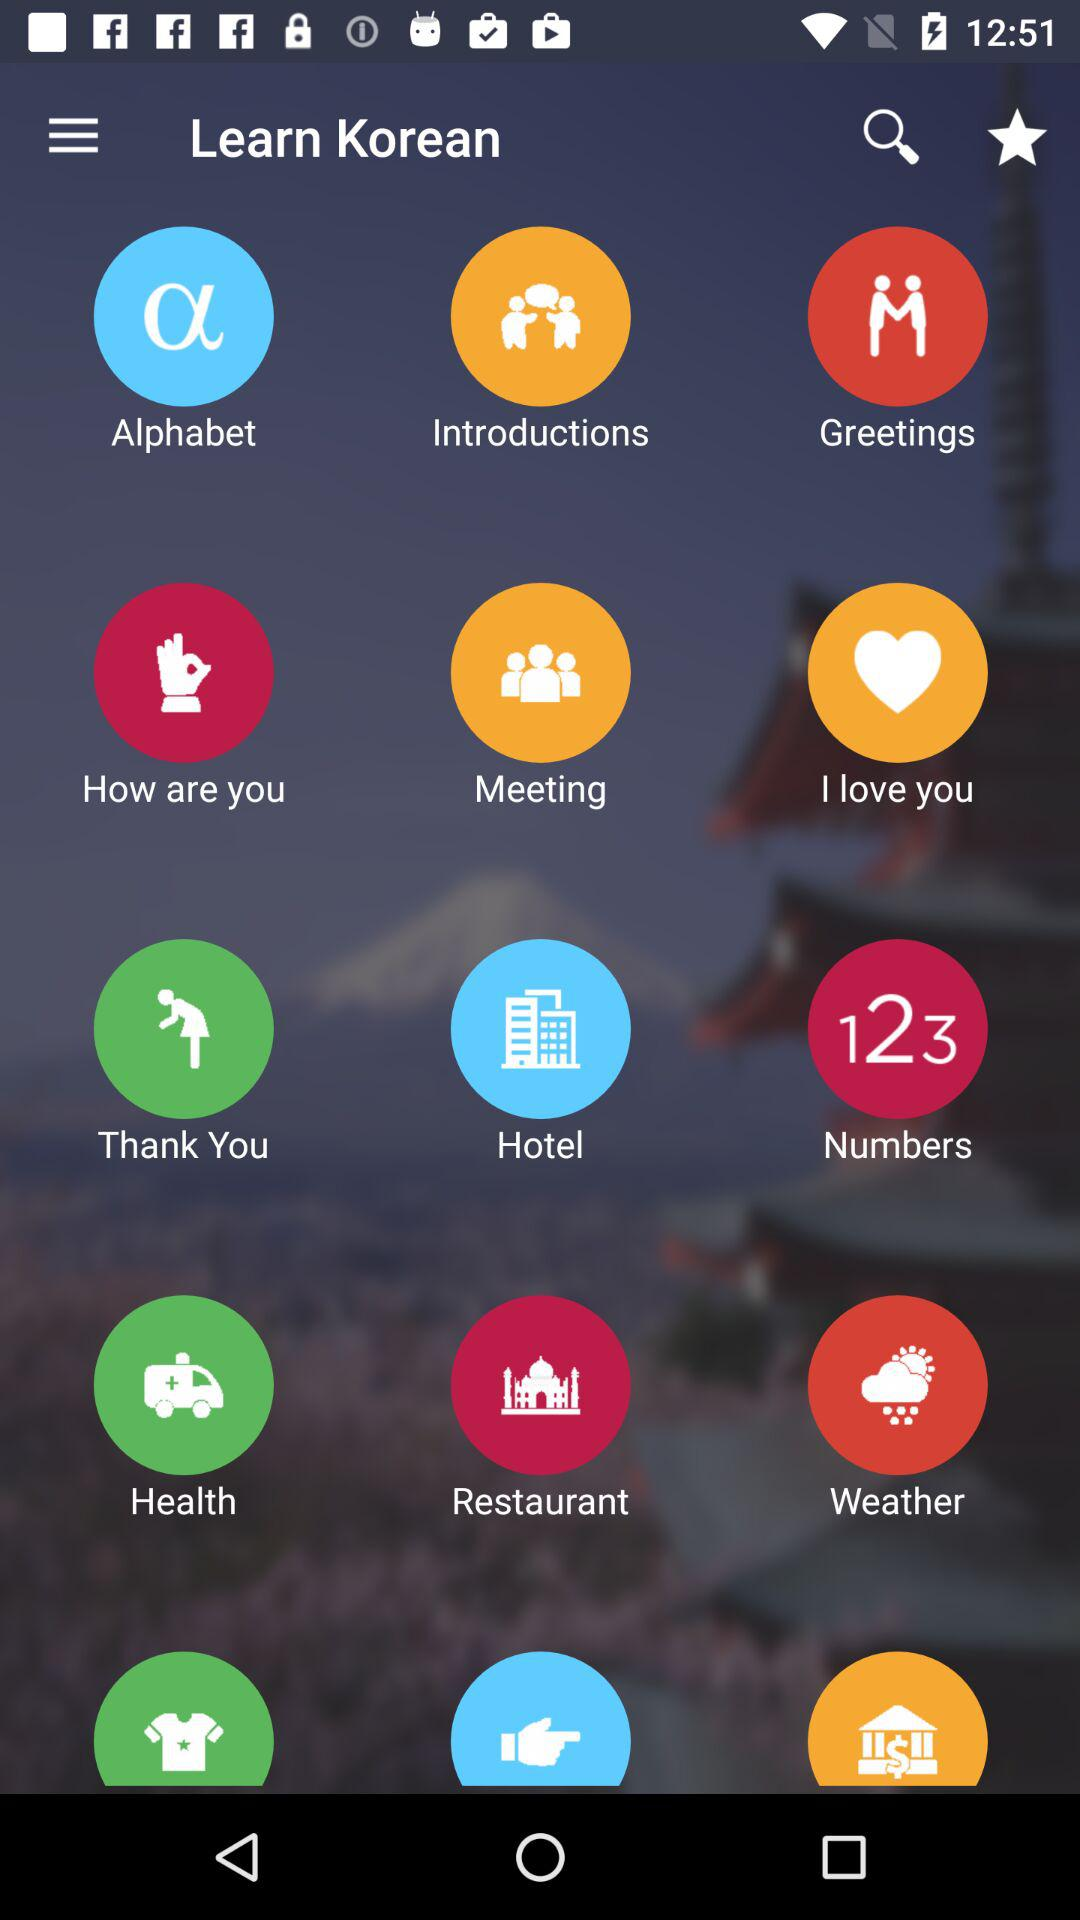Which version of the application is this?
When the provided information is insufficient, respond with <no answer>. <no answer> 